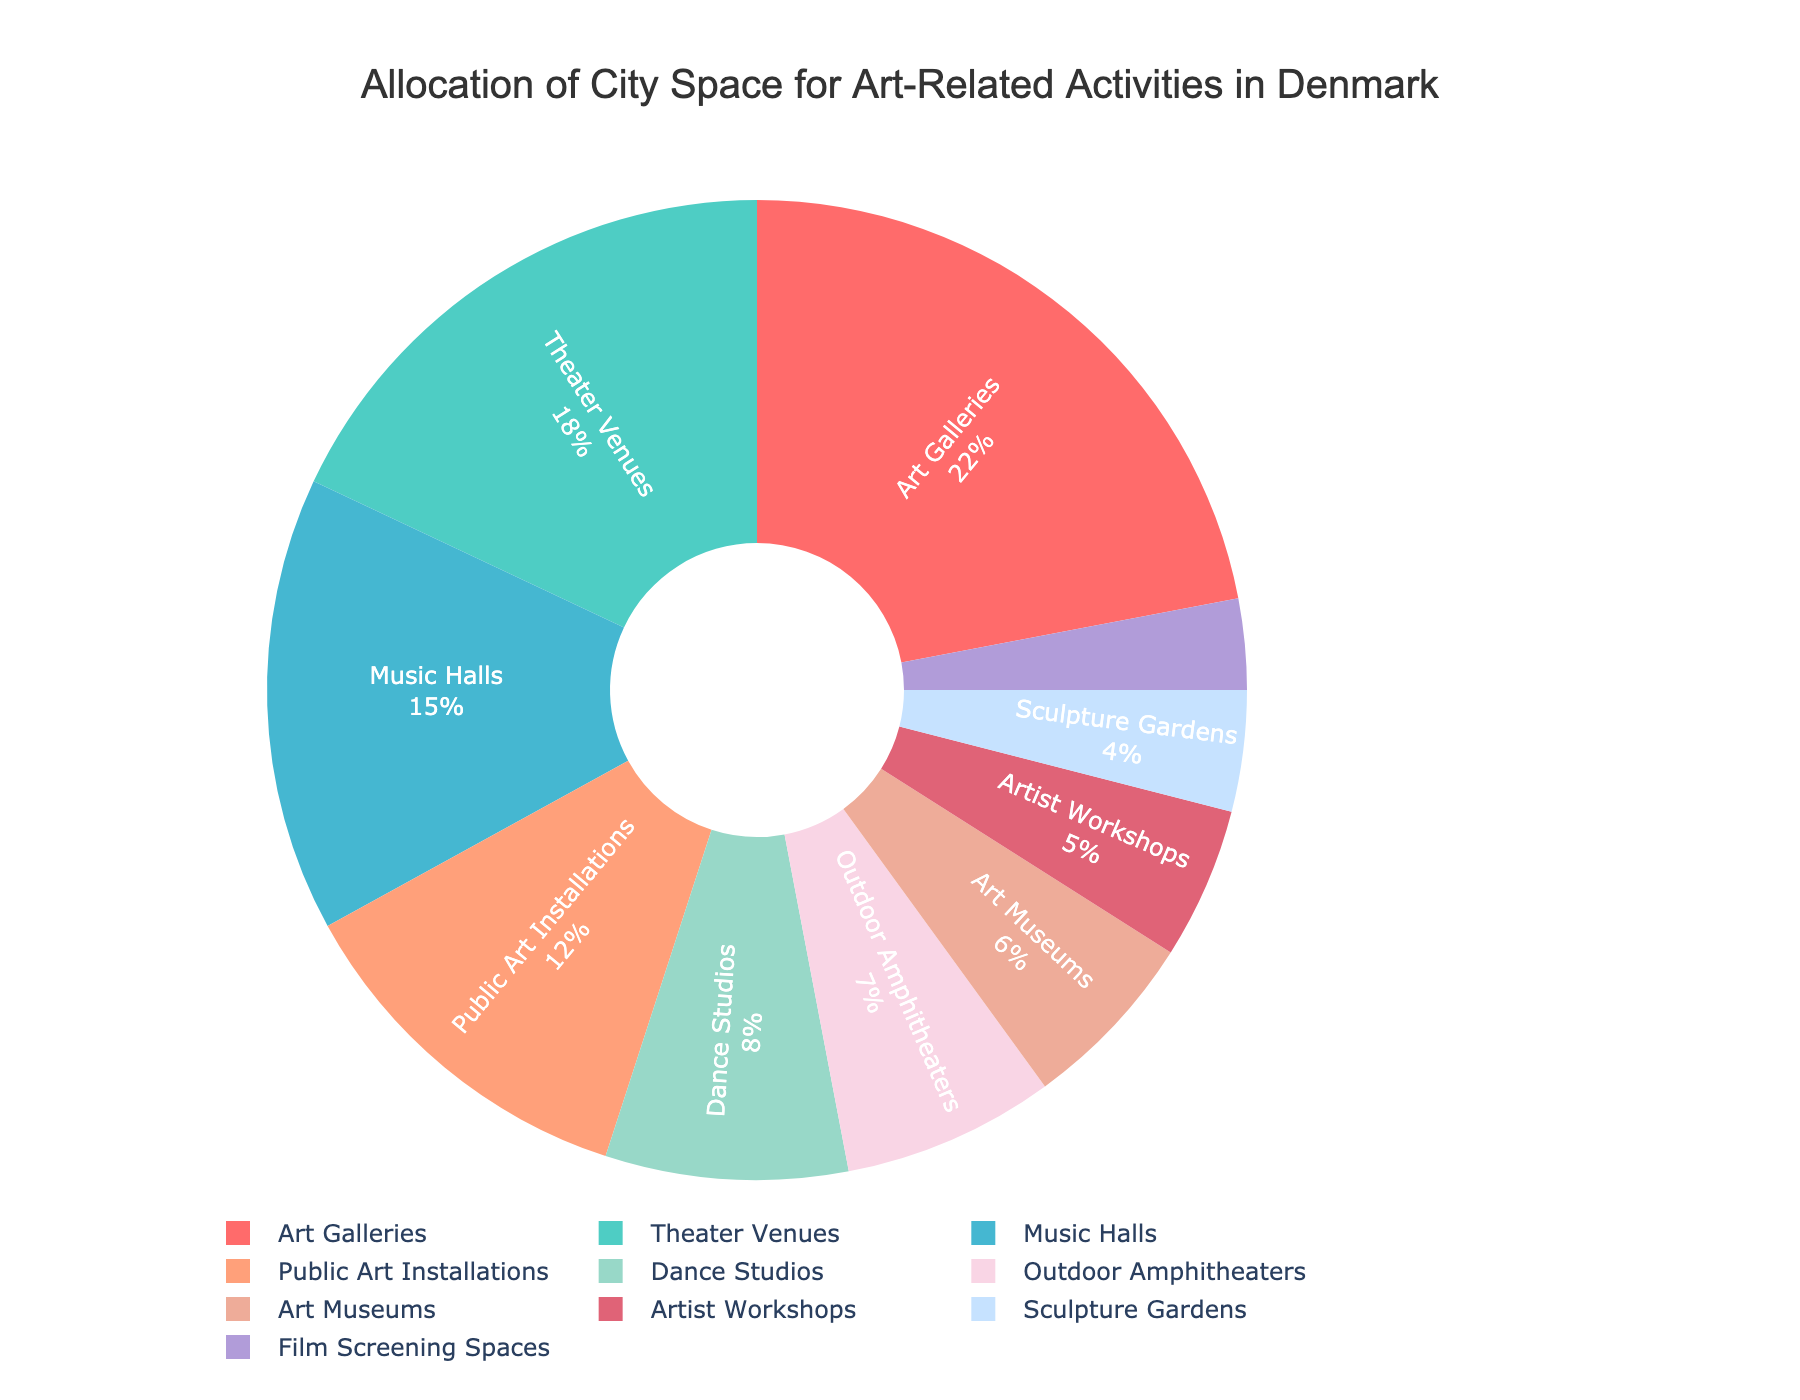How much space is allocated to Art Galleries? According to the pie chart, Art Galleries take up 22% of the city space allocated for art-related activities.
Answer: 22% Which category uses more space: Theater Venues or Music Halls? From the chart, Theater Venues use 18%, while Music Halls use 15%. So Theater Venues use more space.
Answer: Theater Venues What is the combined space allocation for Art Museums and Dance Studios? The space allocated is 6% for Art Museums and 8% for Dance Studios. Adding these together: 6% + 8% = 14%.
Answer: 14% Which category has the least allocation of space? From the chart, Film Screening Spaces have the least allocation of 3%.
Answer: Film Screening Spaces How much more space is allocated to Music Halls compared to Sculpture Gardens? Music Halls use 15%, and Sculpture Gardens use 4%. The difference is 15% - 4% = 11%.
Answer: 11% Are there more space allocations for Outdoor Amphitheaters or Artist Workshops, and by how much? Outdoor Amphitheaters use 7%, whereas Artist Workshops use 5%. Outdoor Amphitheaters use 7% - 5% = 2% more.
Answer: Outdoor Amphitheaters by 2% What percentage of the city space is allocated to categories that use less than 10% each? The categories using less than 10% are Dance Studios, Outdoor Amphitheaters, Art Museums, Artist Workshops, Sculpture Gardens, and Film Screening Spaces. Adding these: 8% + 7% + 6% + 5% + 4% + 3% = 33%.
Answer: 33% Which category is represented by the second-largest segment in the chart? The second-largest segment is for Theater Venues, which use 18% of the city space.
Answer: Theater Venues How much combined city space do Public Art Installations, Outdoor Amphitheaters, and Sculpture Gardens cover? Adding their percentages: Public Art Installations (12%), Outdoor Amphitheaters (7%), and Sculpture Gardens (4%): 12% + 7% + 4% = 23%.
Answer: 23% Does the space for Art Galleries and Music Halls together exceed 30%? Art Galleries use 22%, and Music Halls use 15%. Adding these together: 22% + 15% = 37%, which is greater than 30%.
Answer: Yes 